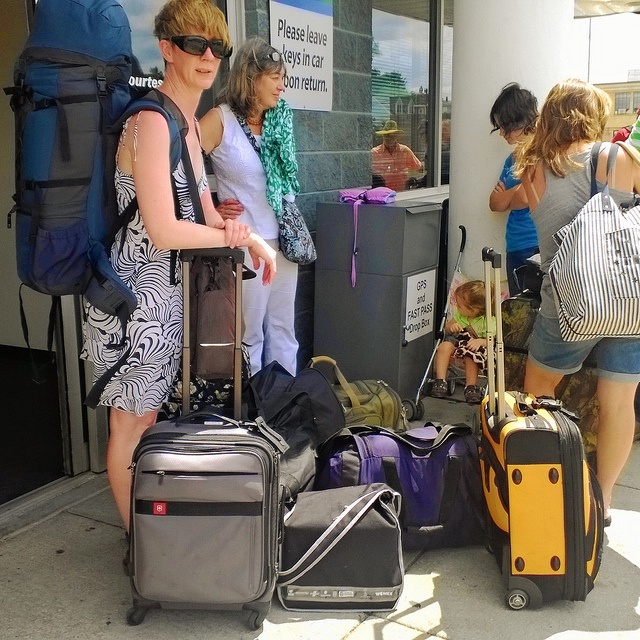Describe the objects in this image and their specific colors. I can see people in black, navy, lightpink, and gray tones, backpack in black, navy, gray, and blue tones, suitcase in black, gray, and darkgray tones, suitcase in black, orange, and maroon tones, and people in black, gray, tan, and darkgray tones in this image. 